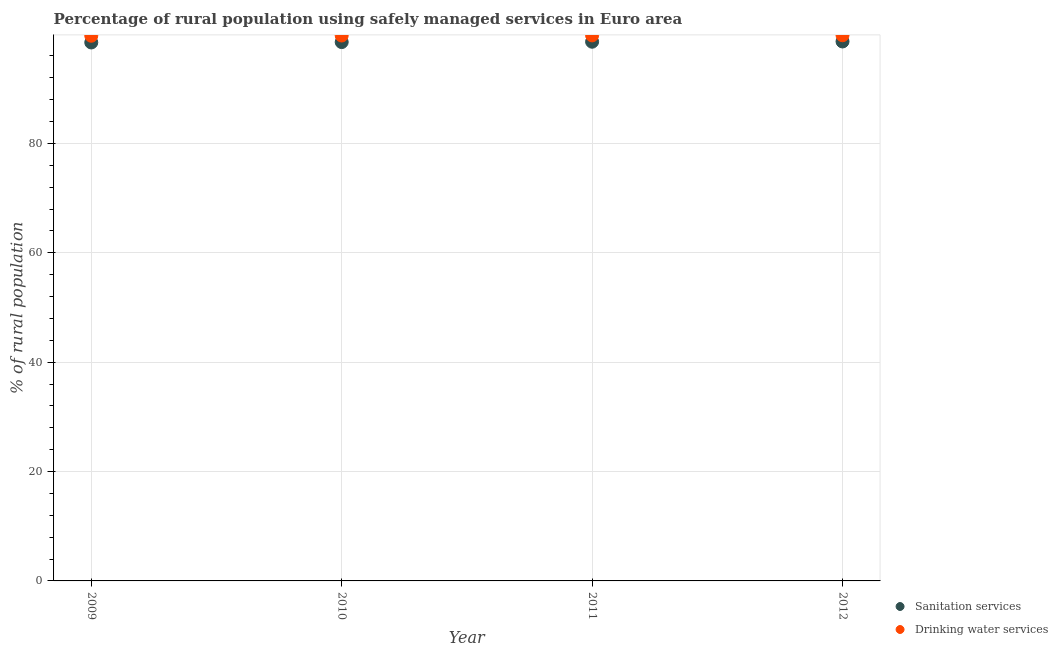How many different coloured dotlines are there?
Offer a terse response. 2. What is the percentage of rural population who used drinking water services in 2011?
Provide a succinct answer. 99.76. Across all years, what is the maximum percentage of rural population who used sanitation services?
Give a very brief answer. 98.65. Across all years, what is the minimum percentage of rural population who used drinking water services?
Offer a very short reply. 99.69. In which year was the percentage of rural population who used sanitation services maximum?
Give a very brief answer. 2012. In which year was the percentage of rural population who used drinking water services minimum?
Provide a short and direct response. 2009. What is the total percentage of rural population who used sanitation services in the graph?
Provide a succinct answer. 394.25. What is the difference between the percentage of rural population who used drinking water services in 2009 and that in 2010?
Make the answer very short. -0.04. What is the difference between the percentage of rural population who used drinking water services in 2010 and the percentage of rural population who used sanitation services in 2012?
Offer a very short reply. 1.09. What is the average percentage of rural population who used sanitation services per year?
Ensure brevity in your answer.  98.56. In the year 2011, what is the difference between the percentage of rural population who used drinking water services and percentage of rural population who used sanitation services?
Keep it short and to the point. 1.16. In how many years, is the percentage of rural population who used drinking water services greater than 68 %?
Offer a terse response. 4. What is the ratio of the percentage of rural population who used drinking water services in 2010 to that in 2012?
Ensure brevity in your answer.  1. Is the percentage of rural population who used drinking water services in 2011 less than that in 2012?
Offer a very short reply. Yes. What is the difference between the highest and the second highest percentage of rural population who used sanitation services?
Provide a short and direct response. 0.05. What is the difference between the highest and the lowest percentage of rural population who used sanitation services?
Your answer should be compact. 0.18. Does the percentage of rural population who used sanitation services monotonically increase over the years?
Make the answer very short. Yes. Is the percentage of rural population who used drinking water services strictly greater than the percentage of rural population who used sanitation services over the years?
Offer a very short reply. Yes. Is the percentage of rural population who used drinking water services strictly less than the percentage of rural population who used sanitation services over the years?
Provide a succinct answer. No. What is the difference between two consecutive major ticks on the Y-axis?
Your response must be concise. 20. Does the graph contain any zero values?
Your answer should be compact. No. Does the graph contain grids?
Your response must be concise. Yes. Where does the legend appear in the graph?
Your answer should be compact. Bottom right. How are the legend labels stacked?
Your answer should be compact. Vertical. What is the title of the graph?
Give a very brief answer. Percentage of rural population using safely managed services in Euro area. Does "Private credit bureau" appear as one of the legend labels in the graph?
Provide a short and direct response. No. What is the label or title of the Y-axis?
Provide a short and direct response. % of rural population. What is the % of rural population of Sanitation services in 2009?
Give a very brief answer. 98.46. What is the % of rural population of Drinking water services in 2009?
Ensure brevity in your answer.  99.69. What is the % of rural population in Sanitation services in 2010?
Your answer should be compact. 98.54. What is the % of rural population in Drinking water services in 2010?
Give a very brief answer. 99.74. What is the % of rural population in Sanitation services in 2011?
Your answer should be compact. 98.6. What is the % of rural population of Drinking water services in 2011?
Provide a short and direct response. 99.76. What is the % of rural population in Sanitation services in 2012?
Your response must be concise. 98.65. What is the % of rural population of Drinking water services in 2012?
Your response must be concise. 99.79. Across all years, what is the maximum % of rural population of Sanitation services?
Your response must be concise. 98.65. Across all years, what is the maximum % of rural population of Drinking water services?
Offer a terse response. 99.79. Across all years, what is the minimum % of rural population in Sanitation services?
Keep it short and to the point. 98.46. Across all years, what is the minimum % of rural population of Drinking water services?
Your answer should be compact. 99.69. What is the total % of rural population of Sanitation services in the graph?
Keep it short and to the point. 394.25. What is the total % of rural population in Drinking water services in the graph?
Your answer should be compact. 398.97. What is the difference between the % of rural population of Sanitation services in 2009 and that in 2010?
Your answer should be compact. -0.07. What is the difference between the % of rural population of Drinking water services in 2009 and that in 2010?
Your answer should be compact. -0.04. What is the difference between the % of rural population in Sanitation services in 2009 and that in 2011?
Your response must be concise. -0.14. What is the difference between the % of rural population of Drinking water services in 2009 and that in 2011?
Your answer should be very brief. -0.07. What is the difference between the % of rural population in Sanitation services in 2009 and that in 2012?
Your response must be concise. -0.18. What is the difference between the % of rural population in Drinking water services in 2009 and that in 2012?
Keep it short and to the point. -0.09. What is the difference between the % of rural population in Sanitation services in 2010 and that in 2011?
Provide a succinct answer. -0.07. What is the difference between the % of rural population in Drinking water services in 2010 and that in 2011?
Your answer should be very brief. -0.02. What is the difference between the % of rural population in Sanitation services in 2010 and that in 2012?
Make the answer very short. -0.11. What is the difference between the % of rural population in Drinking water services in 2010 and that in 2012?
Provide a succinct answer. -0.05. What is the difference between the % of rural population of Sanitation services in 2011 and that in 2012?
Your response must be concise. -0.05. What is the difference between the % of rural population in Drinking water services in 2011 and that in 2012?
Your response must be concise. -0.03. What is the difference between the % of rural population of Sanitation services in 2009 and the % of rural population of Drinking water services in 2010?
Give a very brief answer. -1.27. What is the difference between the % of rural population in Sanitation services in 2009 and the % of rural population in Drinking water services in 2011?
Offer a terse response. -1.29. What is the difference between the % of rural population in Sanitation services in 2009 and the % of rural population in Drinking water services in 2012?
Provide a short and direct response. -1.32. What is the difference between the % of rural population of Sanitation services in 2010 and the % of rural population of Drinking water services in 2011?
Ensure brevity in your answer.  -1.22. What is the difference between the % of rural population of Sanitation services in 2010 and the % of rural population of Drinking water services in 2012?
Ensure brevity in your answer.  -1.25. What is the difference between the % of rural population of Sanitation services in 2011 and the % of rural population of Drinking water services in 2012?
Your answer should be compact. -1.19. What is the average % of rural population in Sanitation services per year?
Your answer should be compact. 98.56. What is the average % of rural population in Drinking water services per year?
Offer a terse response. 99.74. In the year 2009, what is the difference between the % of rural population of Sanitation services and % of rural population of Drinking water services?
Provide a short and direct response. -1.23. In the year 2010, what is the difference between the % of rural population of Sanitation services and % of rural population of Drinking water services?
Ensure brevity in your answer.  -1.2. In the year 2011, what is the difference between the % of rural population of Sanitation services and % of rural population of Drinking water services?
Provide a succinct answer. -1.16. In the year 2012, what is the difference between the % of rural population of Sanitation services and % of rural population of Drinking water services?
Your answer should be very brief. -1.14. What is the ratio of the % of rural population of Drinking water services in 2009 to that in 2011?
Give a very brief answer. 1. What is the ratio of the % of rural population of Sanitation services in 2009 to that in 2012?
Offer a very short reply. 1. What is the ratio of the % of rural population in Drinking water services in 2009 to that in 2012?
Offer a terse response. 1. What is the ratio of the % of rural population of Drinking water services in 2010 to that in 2011?
Provide a short and direct response. 1. What is the ratio of the % of rural population of Drinking water services in 2010 to that in 2012?
Keep it short and to the point. 1. What is the difference between the highest and the second highest % of rural population in Sanitation services?
Provide a short and direct response. 0.05. What is the difference between the highest and the second highest % of rural population in Drinking water services?
Your answer should be very brief. 0.03. What is the difference between the highest and the lowest % of rural population of Sanitation services?
Keep it short and to the point. 0.18. What is the difference between the highest and the lowest % of rural population in Drinking water services?
Keep it short and to the point. 0.09. 